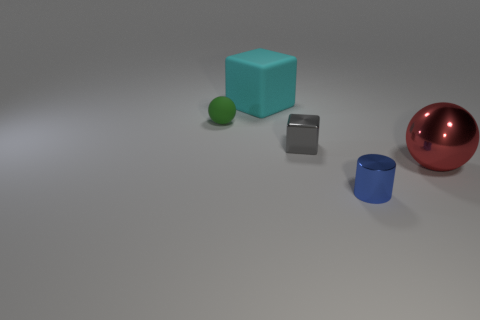Are there any metallic cylinders? yes 